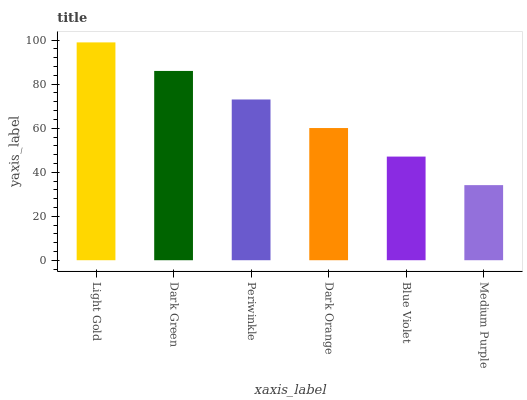Is Medium Purple the minimum?
Answer yes or no. Yes. Is Light Gold the maximum?
Answer yes or no. Yes. Is Dark Green the minimum?
Answer yes or no. No. Is Dark Green the maximum?
Answer yes or no. No. Is Light Gold greater than Dark Green?
Answer yes or no. Yes. Is Dark Green less than Light Gold?
Answer yes or no. Yes. Is Dark Green greater than Light Gold?
Answer yes or no. No. Is Light Gold less than Dark Green?
Answer yes or no. No. Is Periwinkle the high median?
Answer yes or no. Yes. Is Dark Orange the low median?
Answer yes or no. Yes. Is Dark Green the high median?
Answer yes or no. No. Is Medium Purple the low median?
Answer yes or no. No. 